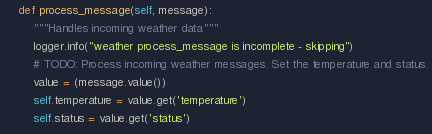<code> <loc_0><loc_0><loc_500><loc_500><_Python_>    def process_message(self, message):
        """Handles incoming weather data"""
        logger.info("weather process_message is incomplete - skipping")
        # TODO: Process incoming weather messages. Set the temperature and status.
        value = (message.value())
        self.temperature = value.get('temperature')
        self.status = value.get('status')
</code> 